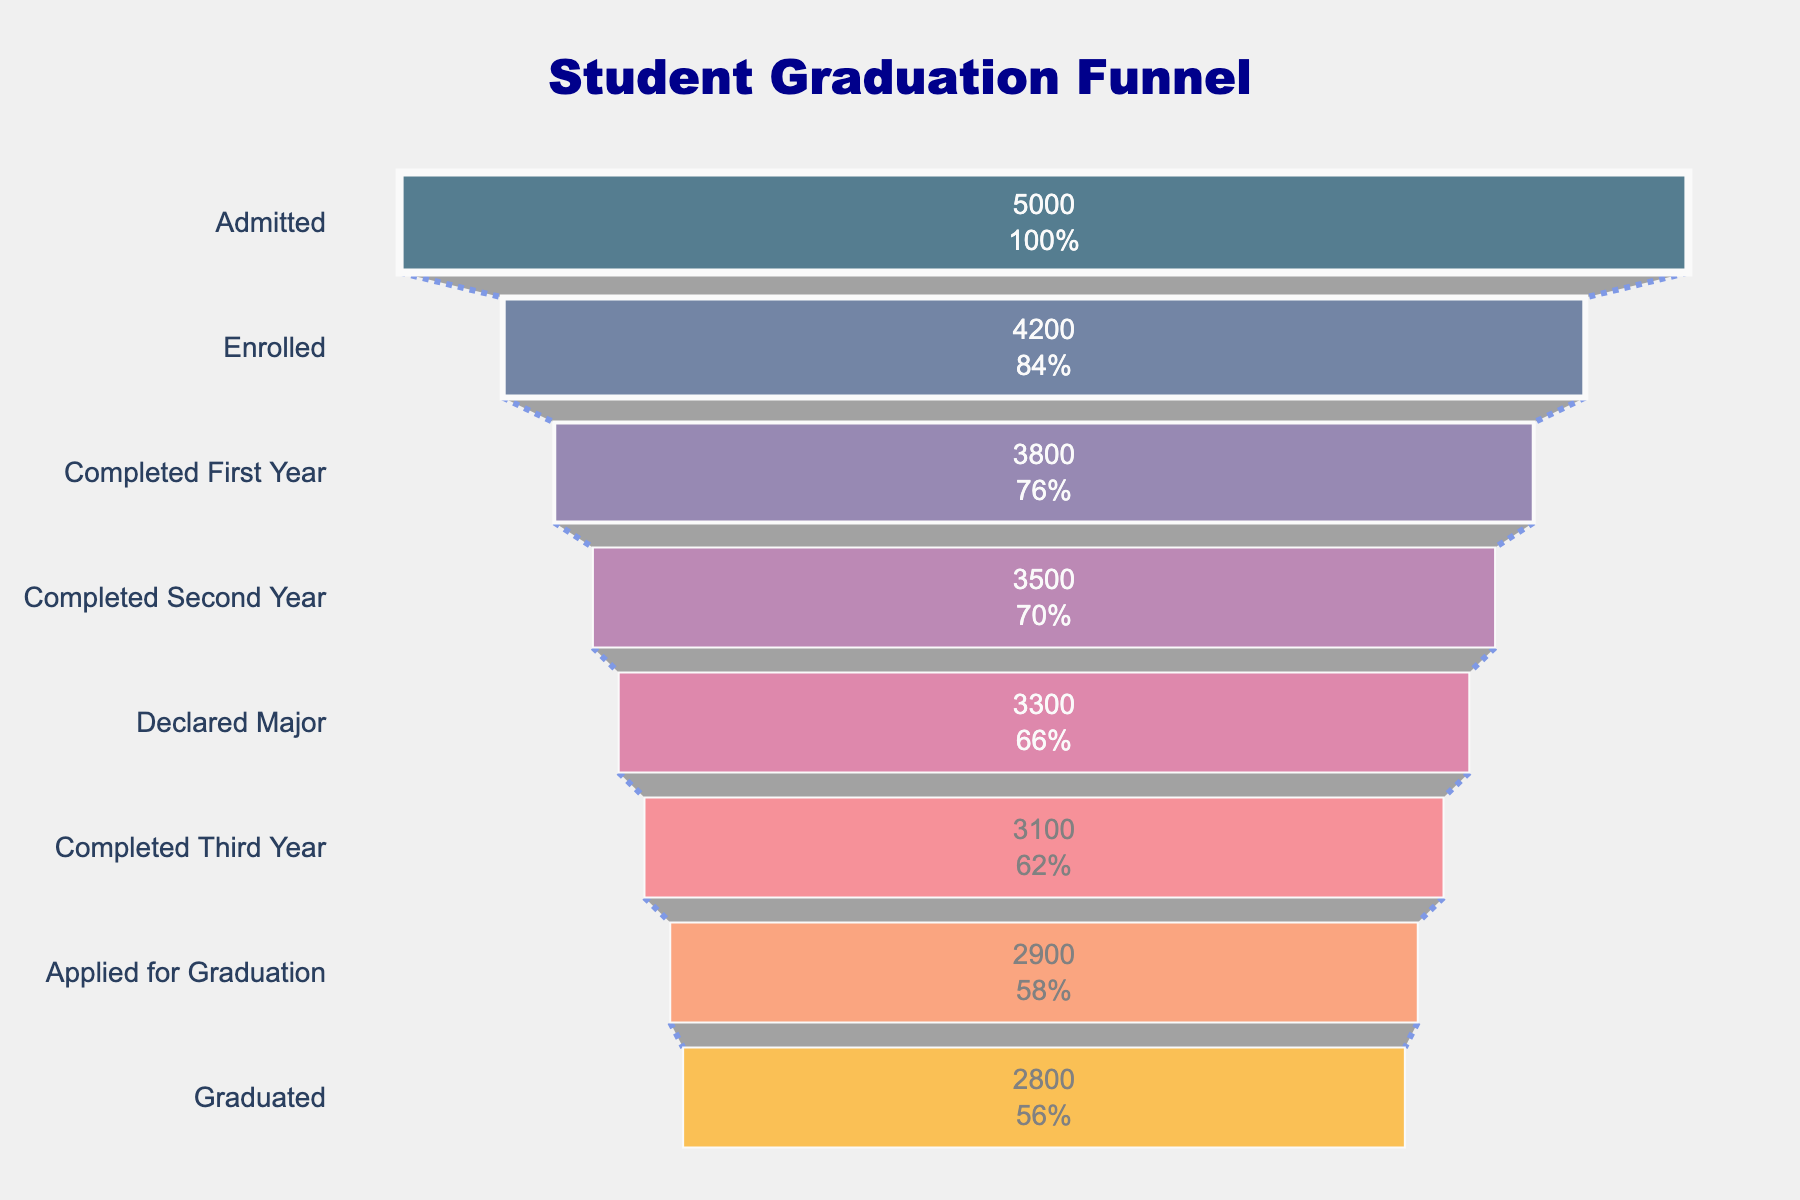What is the title of the funnel chart? The title of the funnel chart is typically displayed prominently at the top of the figure. In this case, the title is specified as "Student Graduation Funnel".
Answer: "Student Graduation Funnel" How many stages are presented in the funnel chart? Counting the number of unique stages listed in the data points, we can determine that there are 8 stages presented.
Answer: 8 Which stage has the highest number of students? The funnel chart shows the number of students at each stage graphically. The stage with the highest number of students is the first one, "Admitted", with 5000 students.
Answer: Admitted What percentage of admitted students graduate? To determine this, find the value for the "Graduated" stage, which is 2800, and divide it by the "Admitted" stage, which is 5000. Multiply the result by 100 to get the percentage. (2800 / 5000) * 100 = 56%.
Answer: 56% Which transition stage has the highest drop-off in student numbers? By examining the differences between consecutive stages, the largest drop-off can be identified. The highest drop is between "Admitted" (5000) and "Enrolled" (4200), with a drop-off of 800 students.
Answer: Admitted to Enrolled How many students are there between "Completed Second Year" and "Declared Major"? Look at the values of the respective stages. "Completed Second Year" has 3500 students, and "Declared Major" has 3300 students. The difference between the two stages is 200 students.
Answer: 200 What is the overall trend from "Admitted" to "Graduated" in terms of student numbers? The trend shows a steady decline in student numbers from the initial stage "Admitted" (5000 students) to the final stage "Graduated" (2800 students). The loss of students gradually reduces at each successive stage.
Answer: Decreasing What is the percentage of students who declared their major and went on to graduate? To calculate this, divide the number of students who graduated (2800) by the number of students who declared their major (3300), then multiply by 100. (2800 / 3300) * 100 ≈ 84.85%.
Answer: ~84.85% How many students did not complete their third year? Find the difference between the number of students who completed the third year (3100) and the total number of students who are at earlier stages excluding this stage. 3800 completed the first year, so 3800 - 3100 = 700 students did not complete their third year.
Answer: 700 